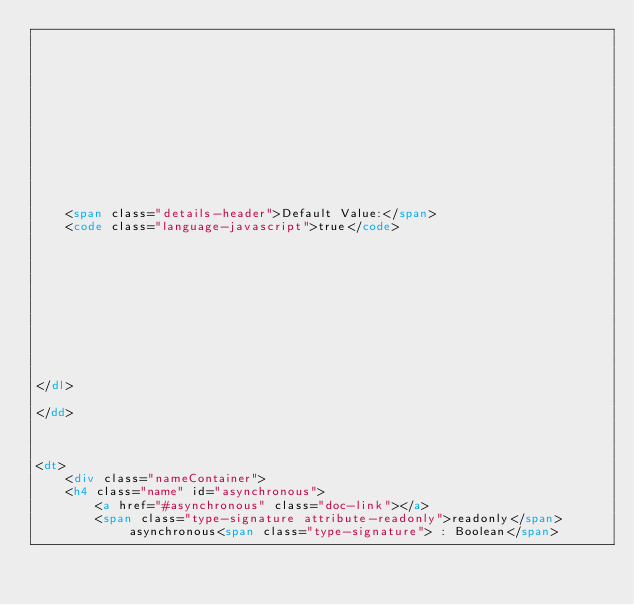<code> <loc_0><loc_0><loc_500><loc_500><_HTML_>    

    

    

    

    

    

    
    <span class="details-header">Default Value:</span>
    <code class="language-javascript">true</code>
    

    

    

    

    

    
</dl>

</dd>

        
            
<dt>
    <div class="nameContainer">
    <h4 class="name" id="asynchronous">
        <a href="#asynchronous" class="doc-link"></a>
        <span class="type-signature attribute-readonly">readonly</span>asynchronous<span class="type-signature"> : Boolean</span></code> 